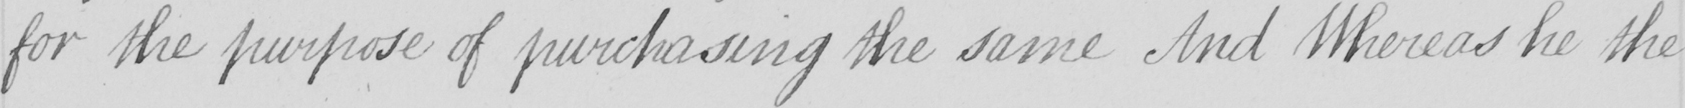Transcribe the text shown in this historical manuscript line. for the purpose of purchasing the same And Whereas he the 